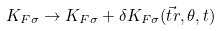Convert formula to latex. <formula><loc_0><loc_0><loc_500><loc_500>K _ { F \sigma } \rightarrow K _ { F \sigma } + \delta K _ { F \sigma } ( \vec { t } r , \theta , t )</formula> 